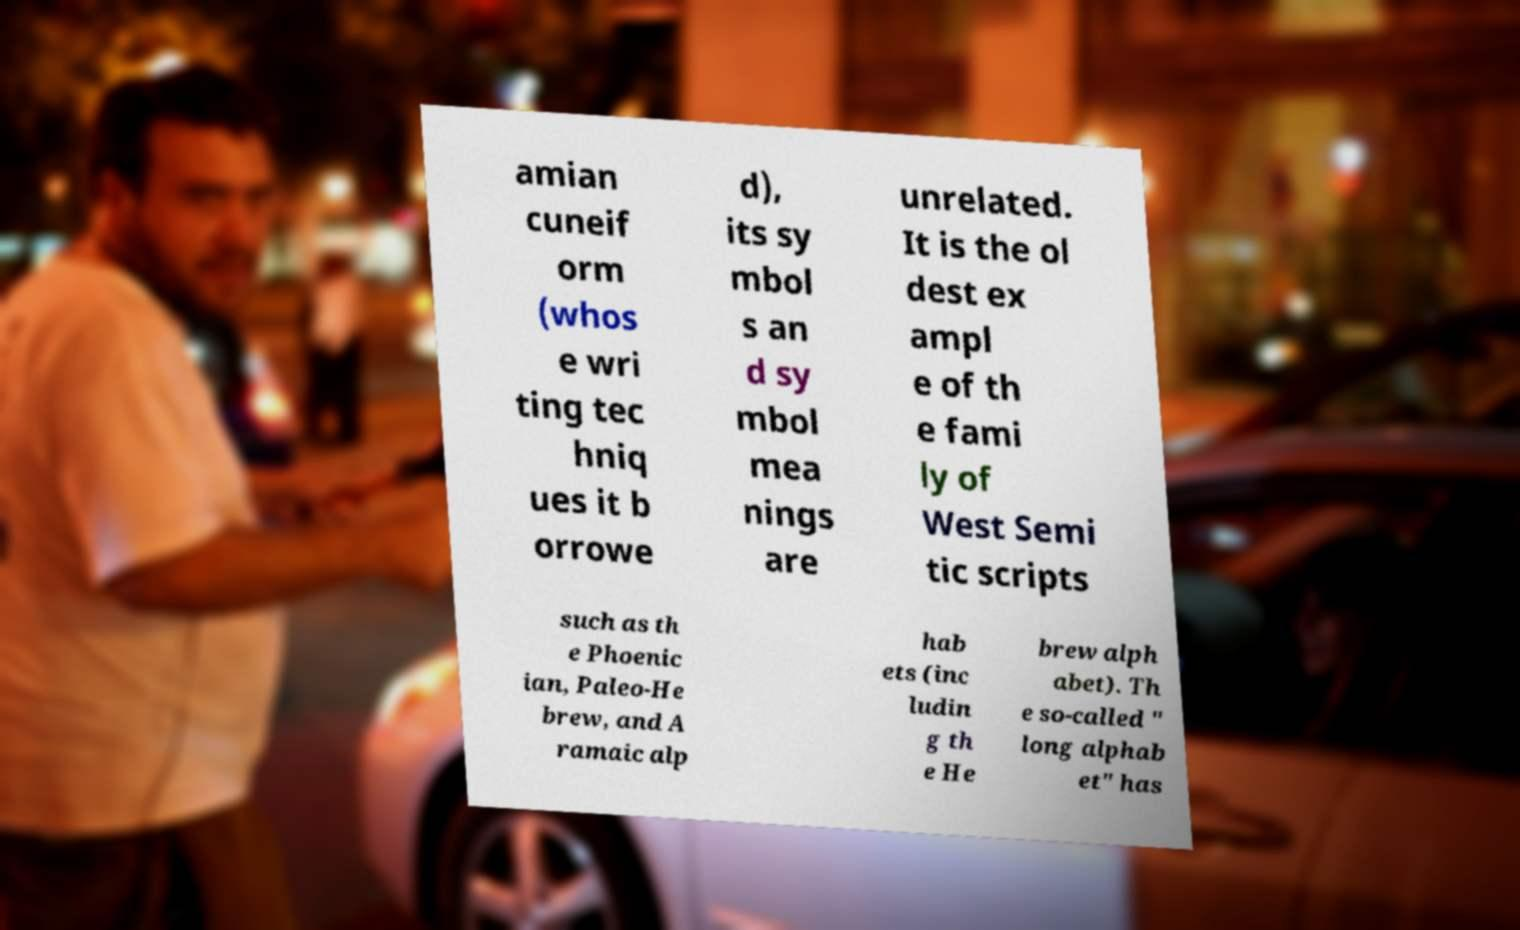Please identify and transcribe the text found in this image. amian cuneif orm (whos e wri ting tec hniq ues it b orrowe d), its sy mbol s an d sy mbol mea nings are unrelated. It is the ol dest ex ampl e of th e fami ly of West Semi tic scripts such as th e Phoenic ian, Paleo-He brew, and A ramaic alp hab ets (inc ludin g th e He brew alph abet). Th e so-called " long alphab et" has 